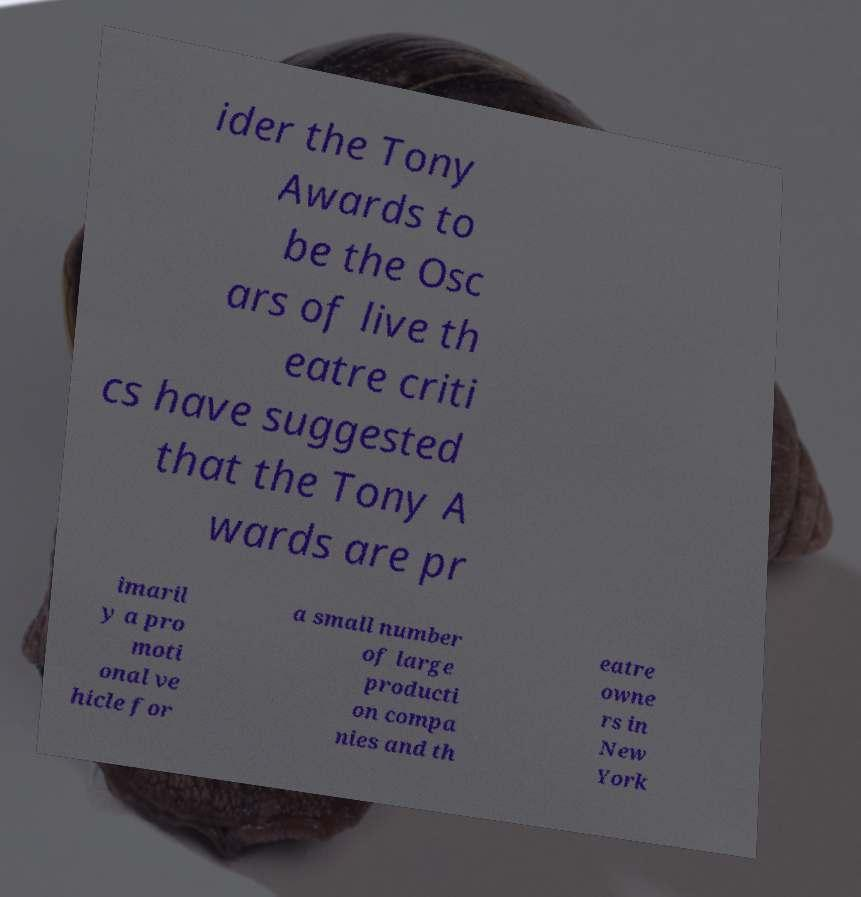There's text embedded in this image that I need extracted. Can you transcribe it verbatim? ider the Tony Awards to be the Osc ars of live th eatre criti cs have suggested that the Tony A wards are pr imaril y a pro moti onal ve hicle for a small number of large producti on compa nies and th eatre owne rs in New York 